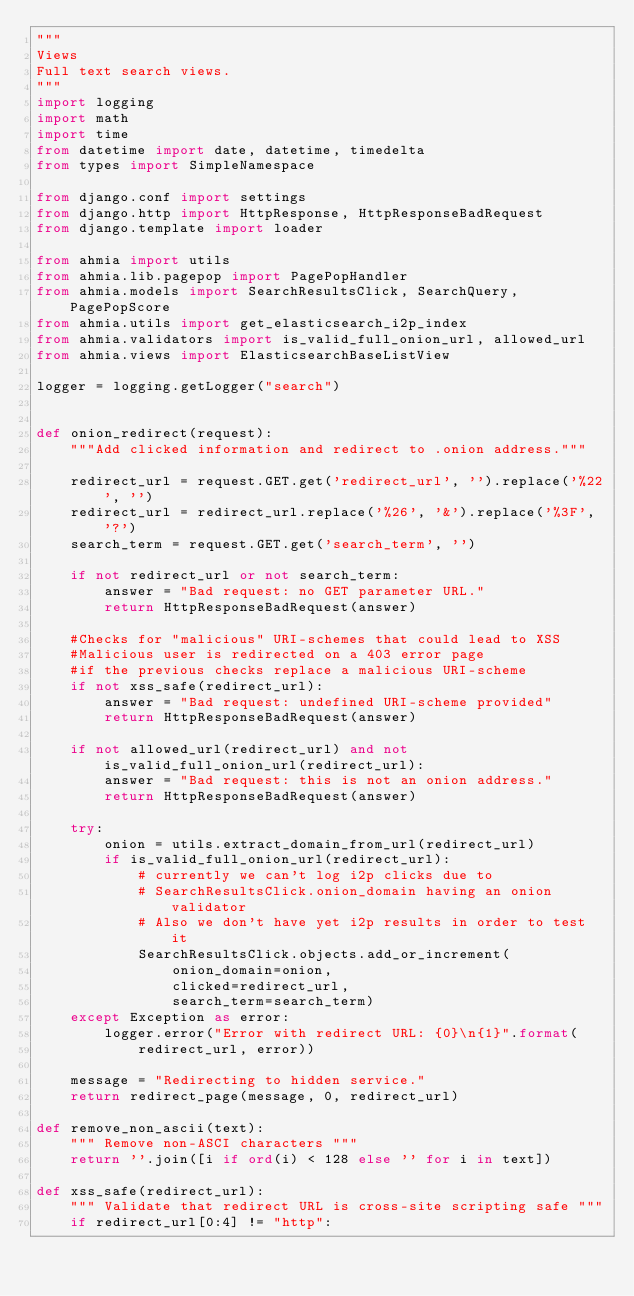Convert code to text. <code><loc_0><loc_0><loc_500><loc_500><_Python_>"""
Views
Full text search views.
"""
import logging
import math
import time
from datetime import date, datetime, timedelta
from types import SimpleNamespace

from django.conf import settings
from django.http import HttpResponse, HttpResponseBadRequest
from django.template import loader

from ahmia import utils
from ahmia.lib.pagepop import PagePopHandler
from ahmia.models import SearchResultsClick, SearchQuery, PagePopScore
from ahmia.utils import get_elasticsearch_i2p_index
from ahmia.validators import is_valid_full_onion_url, allowed_url
from ahmia.views import ElasticsearchBaseListView

logger = logging.getLogger("search")


def onion_redirect(request):
    """Add clicked information and redirect to .onion address."""

    redirect_url = request.GET.get('redirect_url', '').replace('%22', '')
    redirect_url = redirect_url.replace('%26', '&').replace('%3F', '?')
    search_term = request.GET.get('search_term', '')

    if not redirect_url or not search_term:
        answer = "Bad request: no GET parameter URL."
        return HttpResponseBadRequest(answer)

    #Checks for "malicious" URI-schemes that could lead to XSS
    #Malicious user is redirected on a 403 error page
    #if the previous checks replace a malicious URI-scheme
    if not xss_safe(redirect_url):
        answer = "Bad request: undefined URI-scheme provided"
        return HttpResponseBadRequest(answer)

    if not allowed_url(redirect_url) and not is_valid_full_onion_url(redirect_url):
        answer = "Bad request: this is not an onion address."
        return HttpResponseBadRequest(answer)

    try:
        onion = utils.extract_domain_from_url(redirect_url)
        if is_valid_full_onion_url(redirect_url):
            # currently we can't log i2p clicks due to
            # SearchResultsClick.onion_domain having an onion validator
            # Also we don't have yet i2p results in order to test it
            SearchResultsClick.objects.add_or_increment(
                onion_domain=onion,
                clicked=redirect_url,
                search_term=search_term)
    except Exception as error:
        logger.error("Error with redirect URL: {0}\n{1}".format(
            redirect_url, error))

    message = "Redirecting to hidden service."
    return redirect_page(message, 0, redirect_url)

def remove_non_ascii(text):
    """ Remove non-ASCI characters """
    return ''.join([i if ord(i) < 128 else '' for i in text])

def xss_safe(redirect_url):
    """ Validate that redirect URL is cross-site scripting safe """
    if redirect_url[0:4] != "http":</code> 